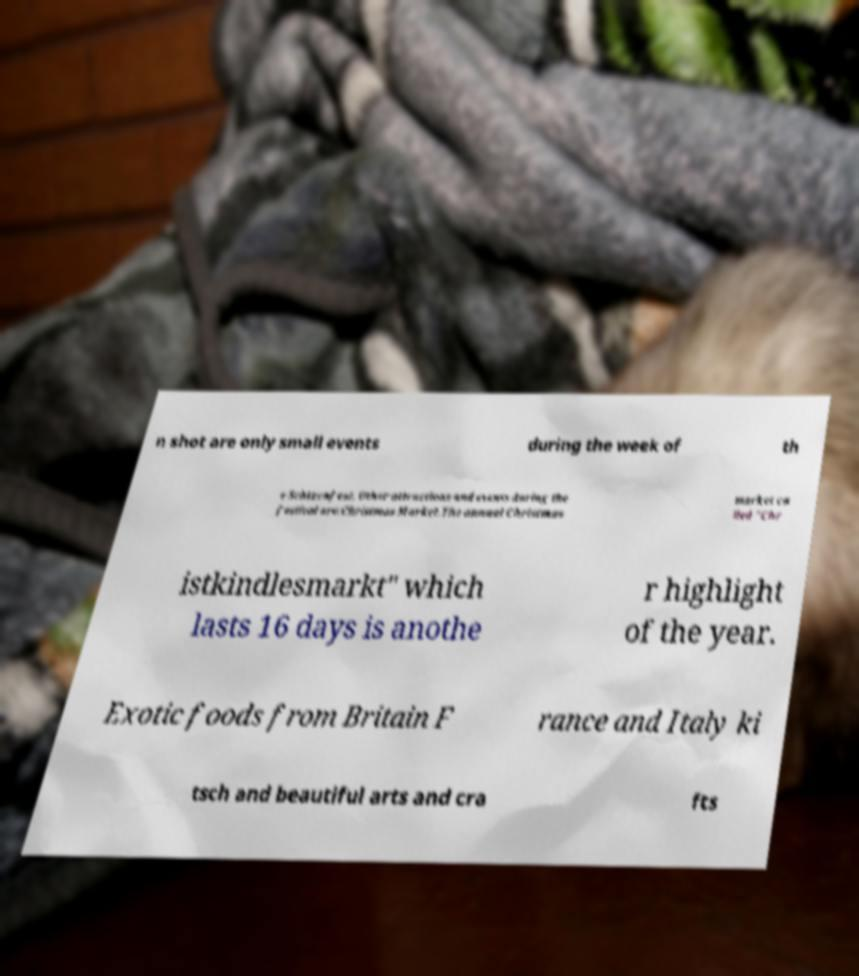Can you accurately transcribe the text from the provided image for me? n shot are only small events during the week of th e Schtzenfest. Other attractions and events during the festival are:Christmas Market.The annual Christmas market ca lled "Chr istkindlesmarkt" which lasts 16 days is anothe r highlight of the year. Exotic foods from Britain F rance and Italy ki tsch and beautiful arts and cra fts 